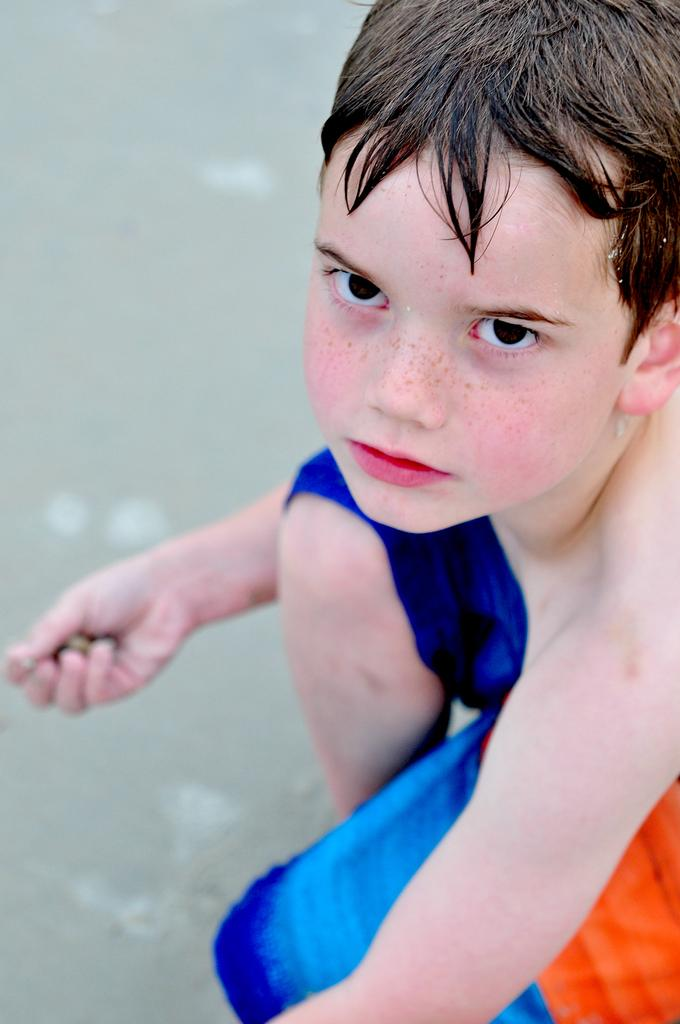What is the main subject of the image? There is a boy in the image. What is the boy doing in the image? The boy is holding objects. Can you describe the environment in the image? There might be water at the bottom of the image. What type of knife is the boy using to cut the cord in the image? There is no knife or cord present in the image. What thrilling activity is the boy participating in the image? The image does not depict any specific activity or thrill; it only shows a boy holding objects. 